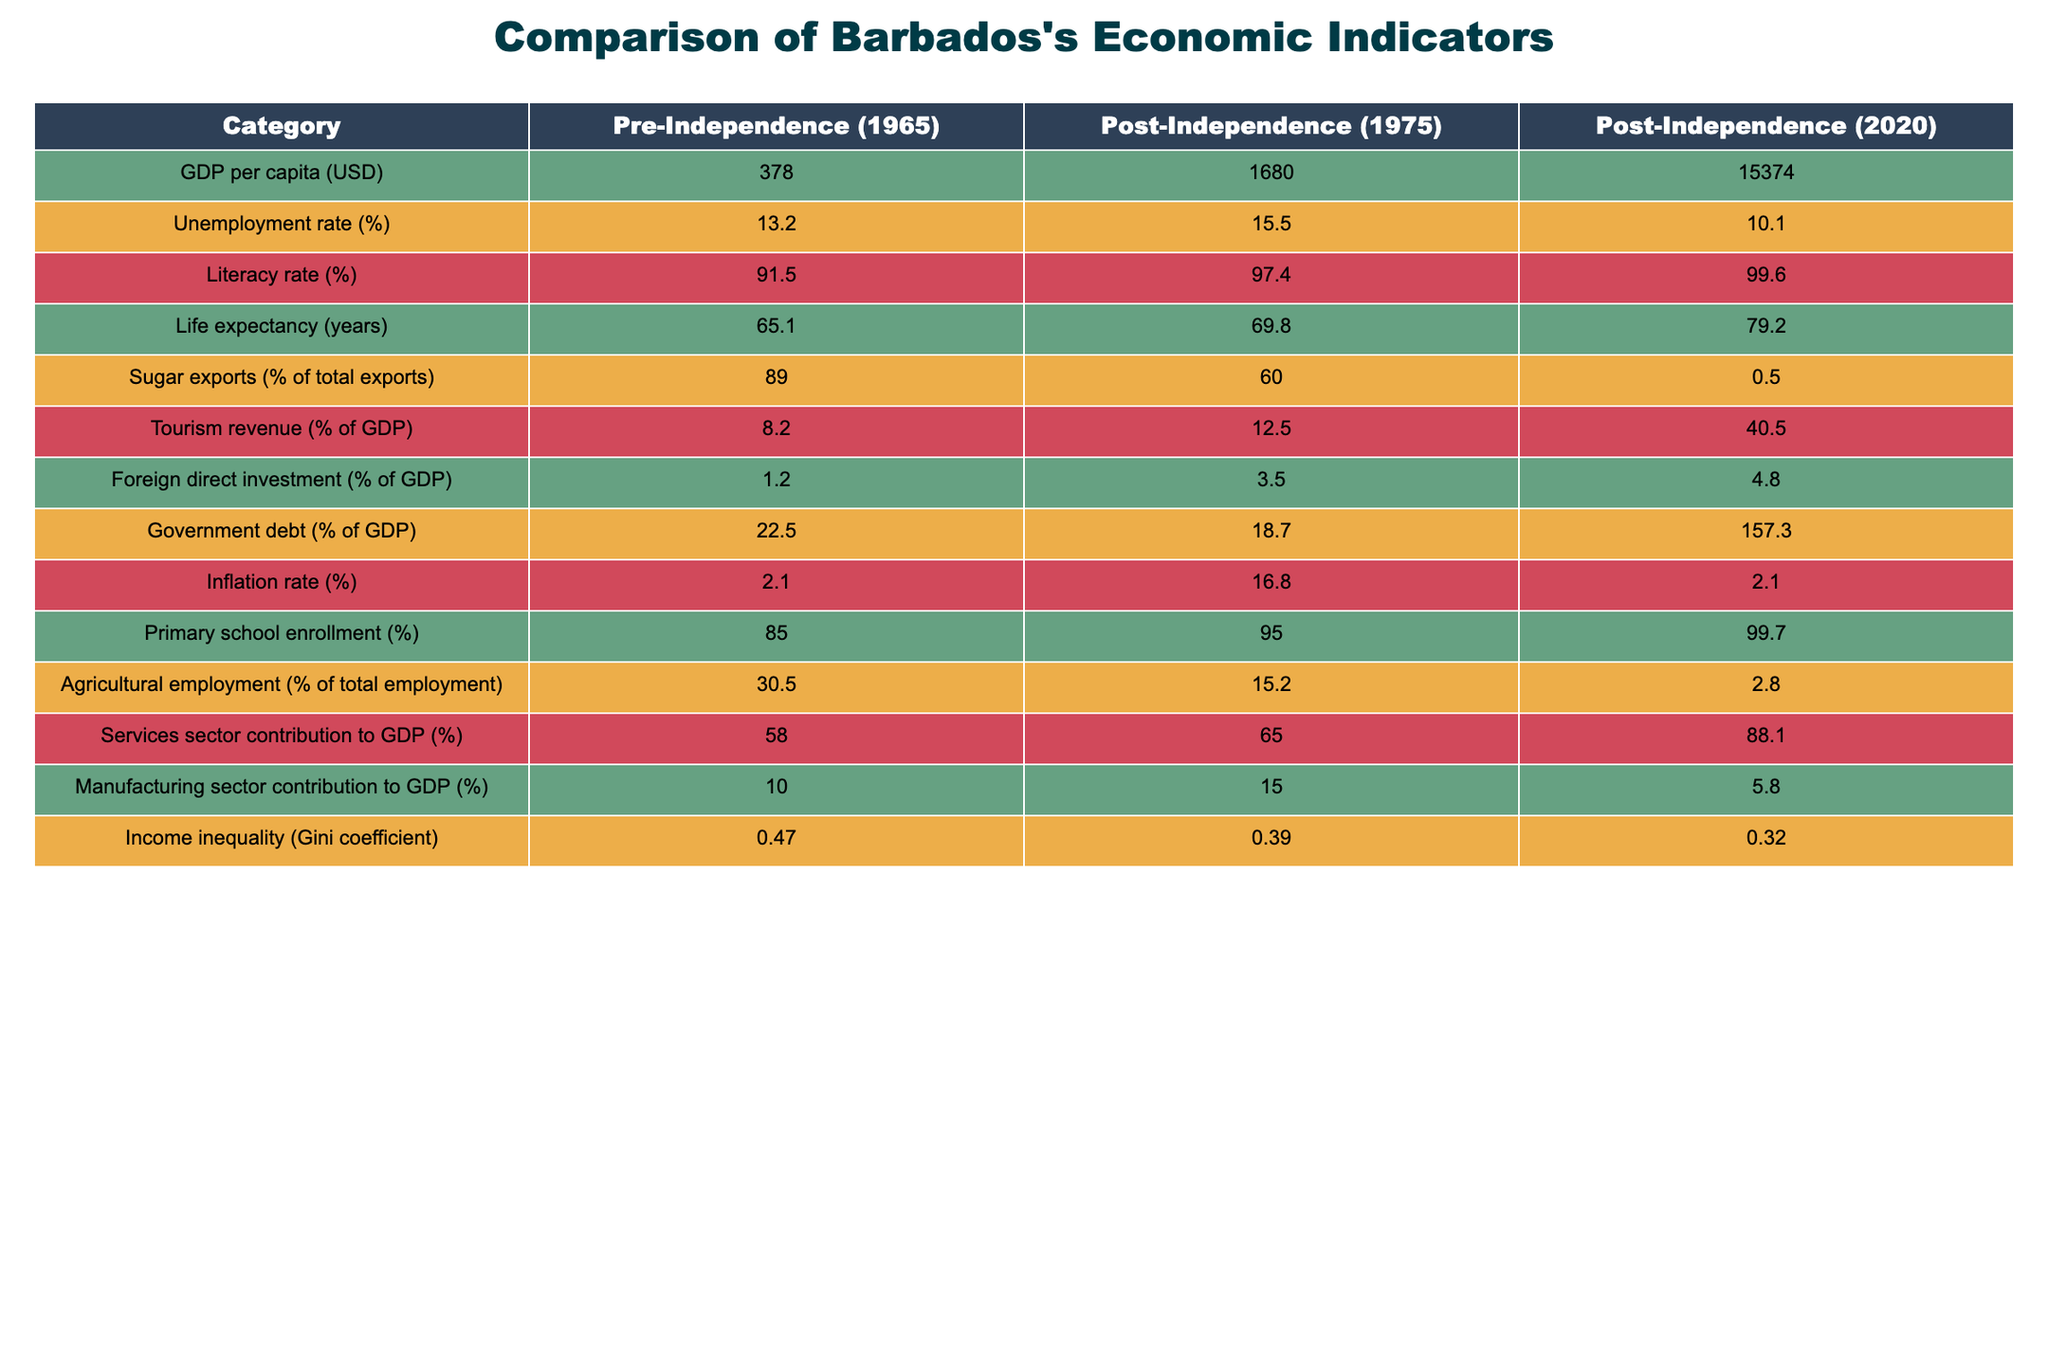What was the GDP per capita in Barbados in 1965? The table shows that the GDP per capita in Barbados in 1965 (pre-independence) is listed as 378 USD.
Answer: 378 USD What is the difference in the unemployment rate between 1975 and 2020? The unemployment rate in 1975 is 15.5%, and in 2020 it is 10.1%. To find the difference, subtract 10.1% from 15.5% which equals 15.5% - 10.1% = 5.4%.
Answer: 5.4% Is the literacy rate higher post-independence compared to pre-independence? The table displays the literacy rates: pre-independence (1965) is 91.5% and post-independence (1975) is 97.4%. Since 97.4% is greater than 91.5%, the statement is true.
Answer: Yes What was the trend in sugar exports as a percentage of total exports from 1965 to 2020? The percentage of sugar exports decreased from 89% in 1965, to 60% in 1975, and further down to 0.5% in 2020. This shows a declining trend over the years.
Answer: Decreasing trend What is the average GDP per capita for the years listed in the table? The GDP per capita figures are 378 USD (1965), 1680 USD (1975), and 15374 USD (2020). Adding these gives 378 + 1680 + 15374 = 17332. Then, dividing by 3 (the number of entries) gives an average of 17332 / 3 = 5777.33 USD.
Answer: 5777.33 USD Did the government debt as a percentage of GDP increase from pre-independence to 2020? Looking at the table, the government debt in 1965 is 22.5%, and in 2020 it is 157.3%. Since 157.3% is greater than 22.5%, we can conclude that government debt increased significantly.
Answer: Yes What percentage of the workforce was employed in agriculture in 1965? The table states that in 1965, 30.5% of the total employment was in agriculture. This figure is directly presented in the table.
Answer: 30.5% What is the Gini coefficient trend from 1965 to 2020? The Gini coefficients for 1965, 1975, and 2020 are 0.47, 0.39, and 0.32 respectively. This shows a decreasing trend, indicating improvements in income inequality over time.
Answer: Decreasing trend What was the percentage contribution of the services sector to GDP in 1975? According to the table, the services sector contributed 65% to GDP in 1975. This value is directly found in the table.
Answer: 65% 